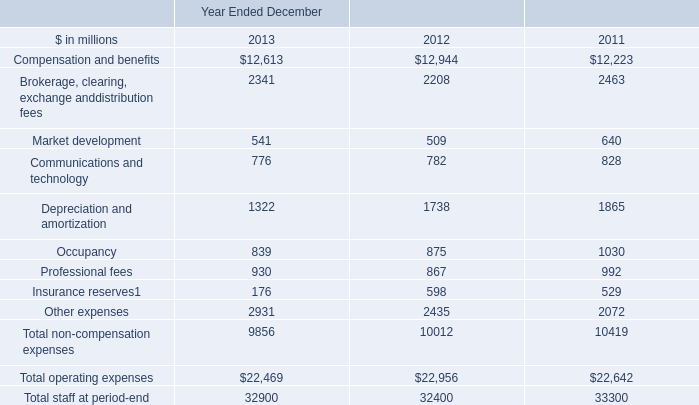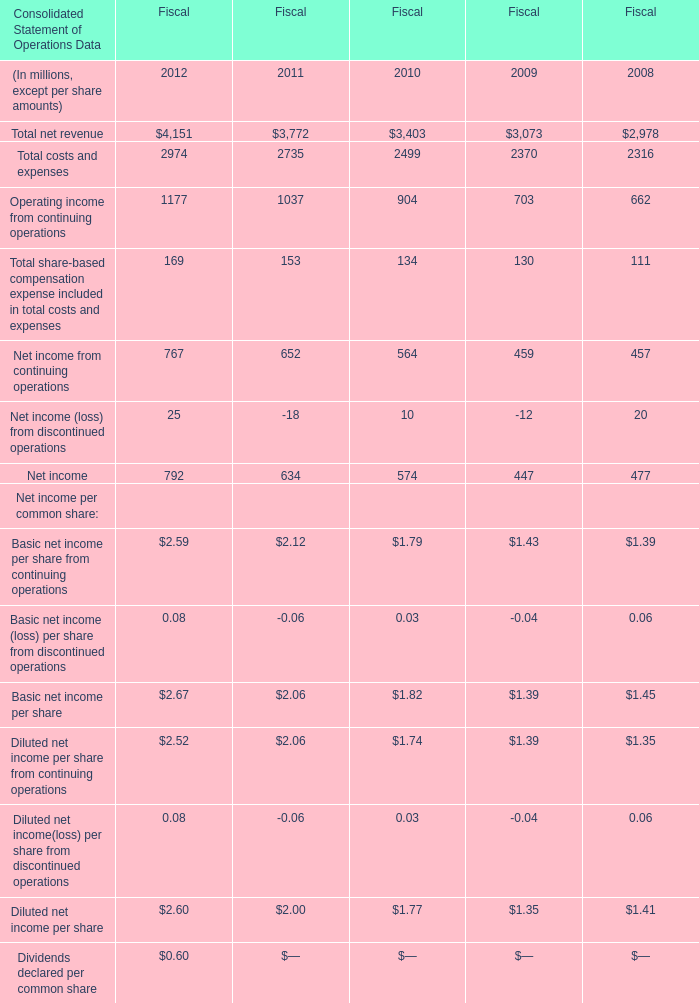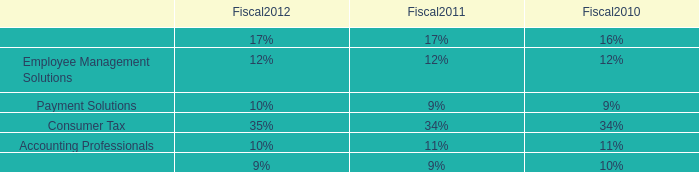what is the net interest income in 2011? 
Computations: (3.88 / (100 - 25))
Answer: 0.05173. 